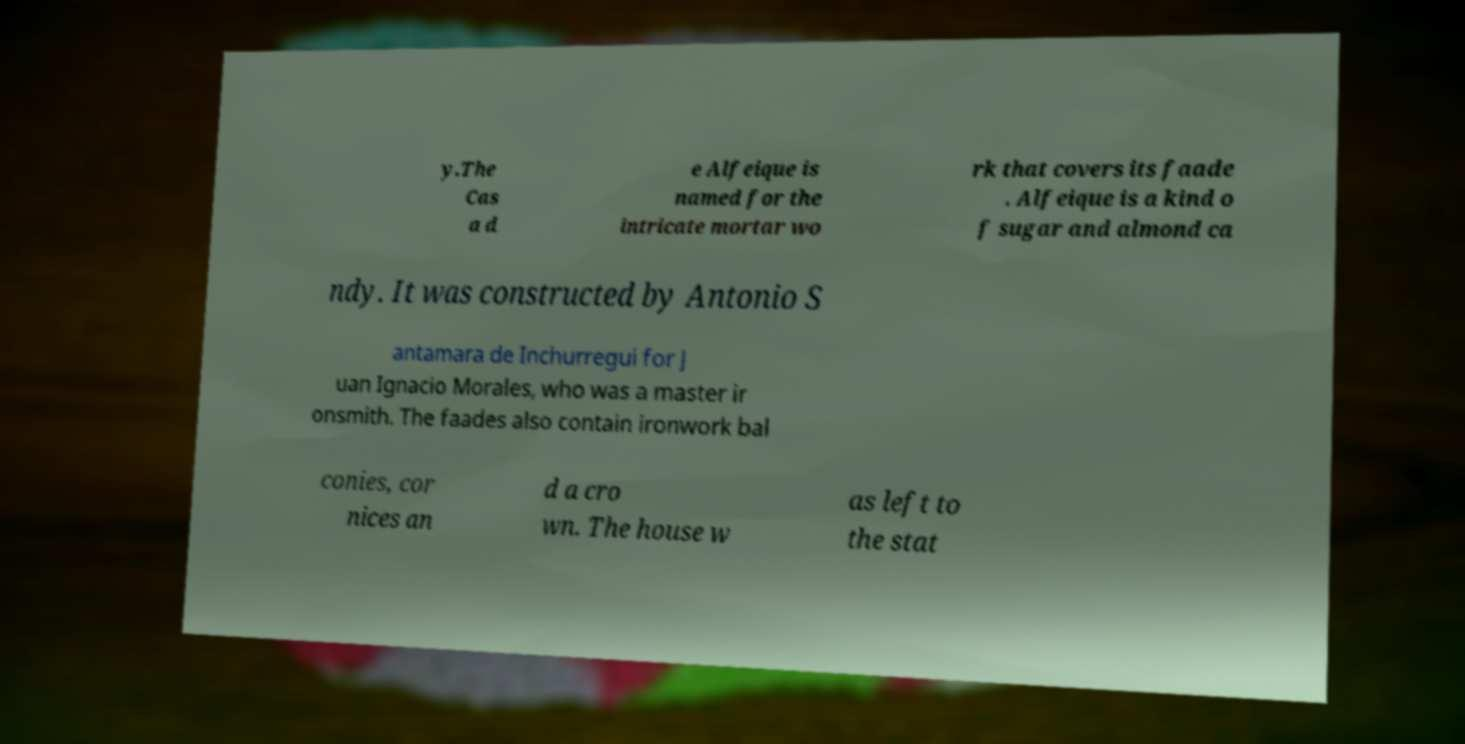Could you assist in decoding the text presented in this image and type it out clearly? y.The Cas a d e Alfeique is named for the intricate mortar wo rk that covers its faade . Alfeique is a kind o f sugar and almond ca ndy. It was constructed by Antonio S antamara de Inchurregui for J uan Ignacio Morales, who was a master ir onsmith. The faades also contain ironwork bal conies, cor nices an d a cro wn. The house w as left to the stat 